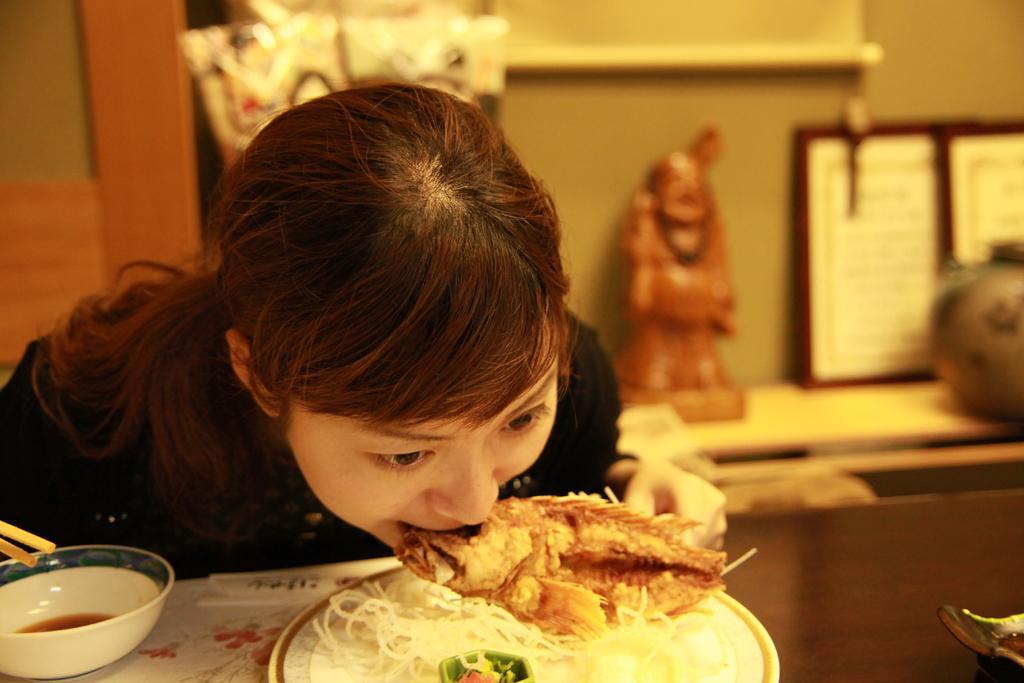Can you describe this image briefly? Here is a girl eating food. This looks like a fish and noodles. This is a table with a plate and bowl placed on it. At background I can see a toy and photo frame and some other object placed on the desk. 